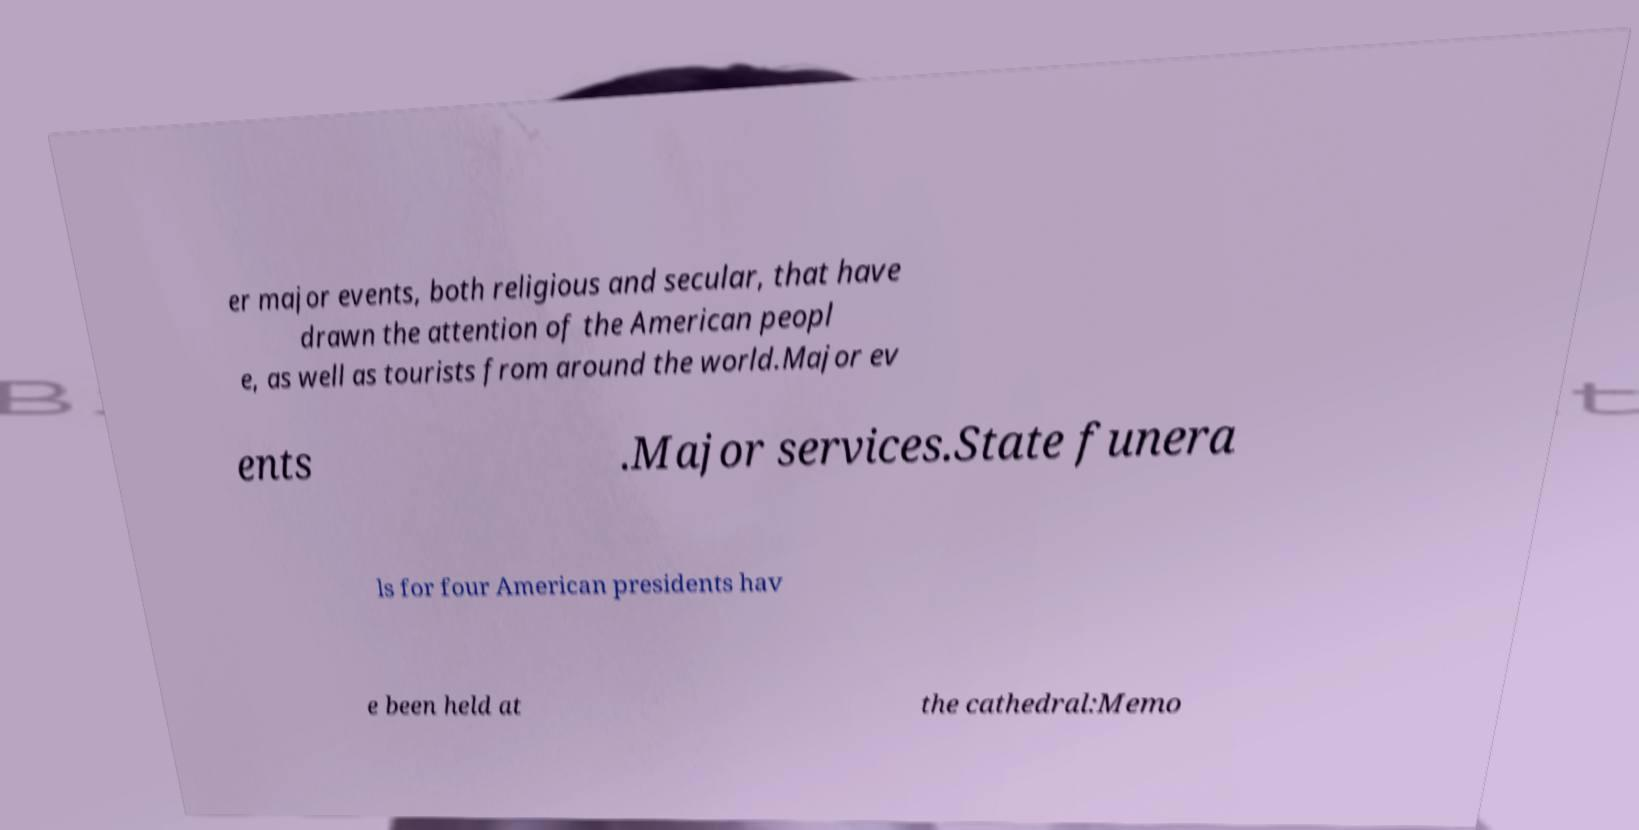For documentation purposes, I need the text within this image transcribed. Could you provide that? er major events, both religious and secular, that have drawn the attention of the American peopl e, as well as tourists from around the world.Major ev ents .Major services.State funera ls for four American presidents hav e been held at the cathedral:Memo 